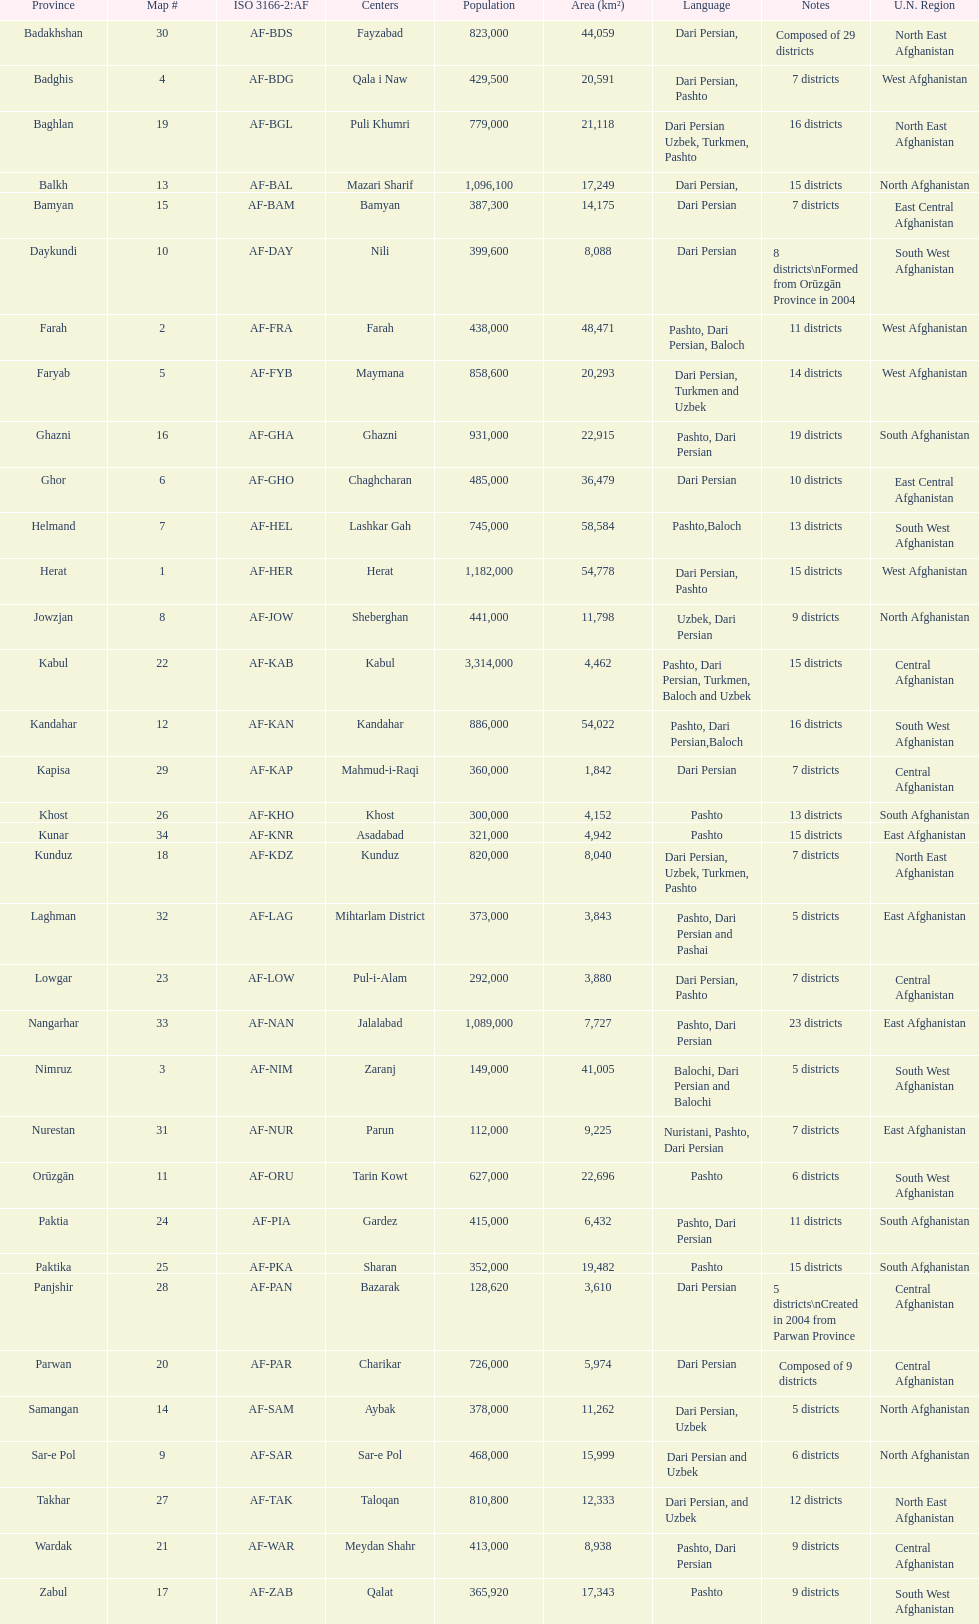Which province has the most districts? Badakhshan. 